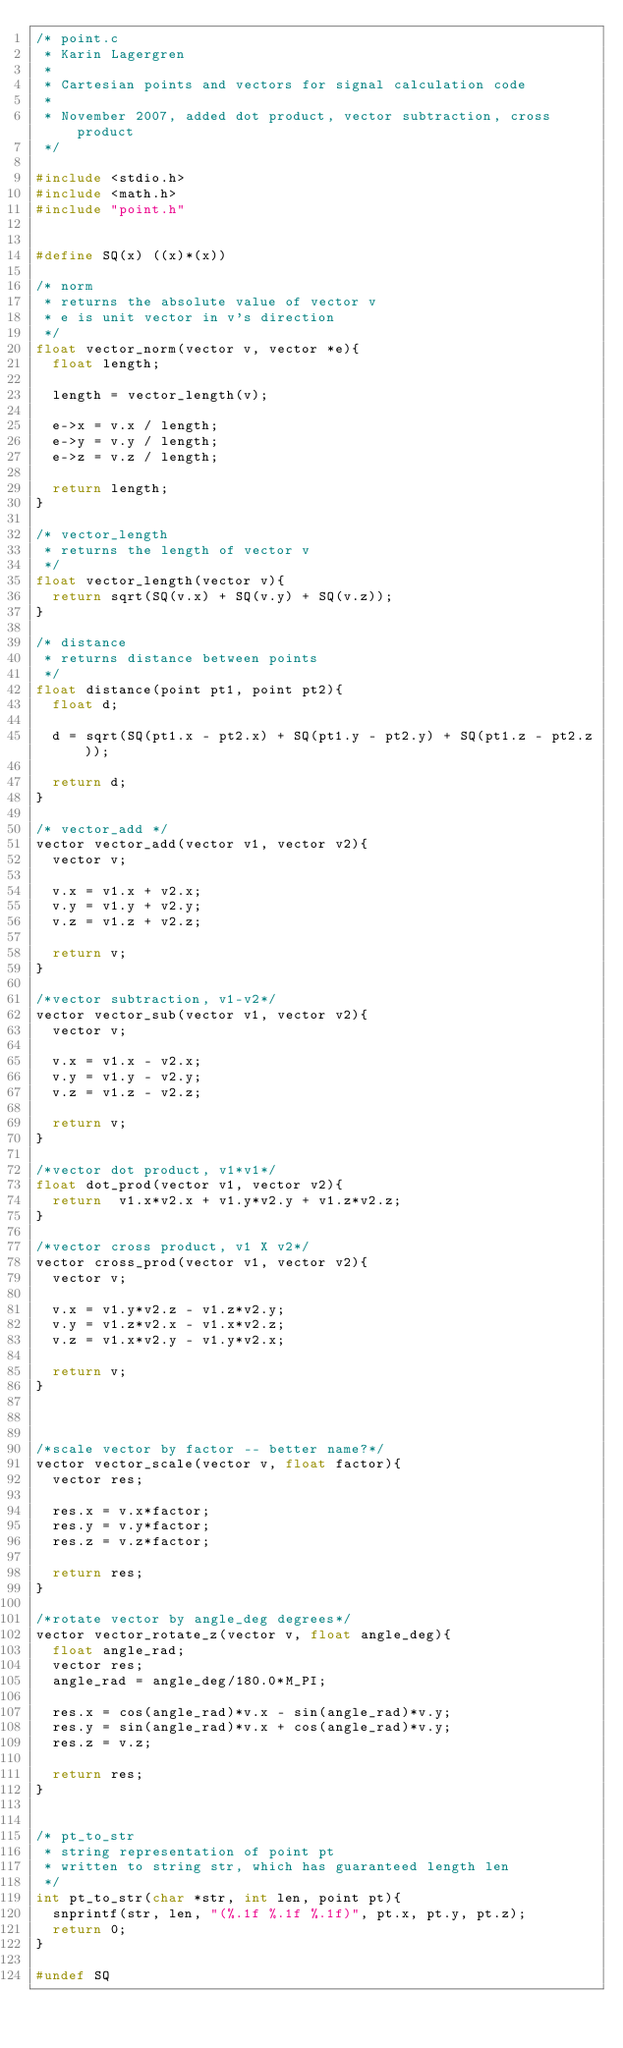Convert code to text. <code><loc_0><loc_0><loc_500><loc_500><_C_>/* point.c
 * Karin Lagergren
 * 
 * Cartesian points and vectors for signal calculation code
 *
 * November 2007, added dot product, vector subtraction, cross product 
 */

#include <stdio.h>
#include <math.h>
#include "point.h"


#define SQ(x) ((x)*(x))

/* norm
 * returns the absolute value of vector v
 * e is unit vector in v's direction
 */
float vector_norm(vector v, vector *e){
  float length;
  
  length = vector_length(v);

  e->x = v.x / length;
  e->y = v.y / length;
  e->z = v.z / length;
  
  return length;
}

/* vector_length
 * returns the length of vector v
 */
float vector_length(vector v){
  return sqrt(SQ(v.x) + SQ(v.y) + SQ(v.z));
}

/* distance
 * returns distance between points
 */
float distance(point pt1, point pt2){
  float d;

  d = sqrt(SQ(pt1.x - pt2.x) + SQ(pt1.y - pt2.y) + SQ(pt1.z - pt2.z));

  return d;
}

/* vector_add */
vector vector_add(vector v1, vector v2){
  vector v;
  
  v.x = v1.x + v2.x;
  v.y = v1.y + v2.y;
  v.z = v1.z + v2.z;

  return v;
}

/*vector subtraction, v1-v2*/
vector vector_sub(vector v1, vector v2){
  vector v;
  
  v.x = v1.x - v2.x;
  v.y = v1.y - v2.y;
  v.z = v1.z - v2.z;
  
  return v;
}

/*vector dot product, v1*v1*/
float dot_prod(vector v1, vector v2){
  return  v1.x*v2.x + v1.y*v2.y + v1.z*v2.z;
}

/*vector cross product, v1 X v2*/
vector cross_prod(vector v1, vector v2){
  vector v;
  
  v.x = v1.y*v2.z - v1.z*v2.y;
  v.y = v1.z*v2.x - v1.x*v2.z;
  v.z = v1.x*v2.y - v1.y*v2.x;

  return v;
}



/*scale vector by factor -- better name?*/
vector vector_scale(vector v, float factor){
  vector res;

  res.x = v.x*factor;
  res.y = v.y*factor;
  res.z = v.z*factor;

  return res;
}

/*rotate vector by angle_deg degrees*/
vector vector_rotate_z(vector v, float angle_deg){
  float angle_rad;
  vector res;
  angle_rad = angle_deg/180.0*M_PI;

  res.x = cos(angle_rad)*v.x - sin(angle_rad)*v.y;
  res.y = sin(angle_rad)*v.x + cos(angle_rad)*v.y;
  res.z = v.z;

  return res;
}


/* pt_to_str
 * string representation of point pt
 * written to string str, which has guaranteed length len 
 */
int pt_to_str(char *str, int len, point pt){
  snprintf(str, len, "(%.1f %.1f %.1f)", pt.x, pt.y, pt.z);
  return 0;
}

#undef SQ
</code> 